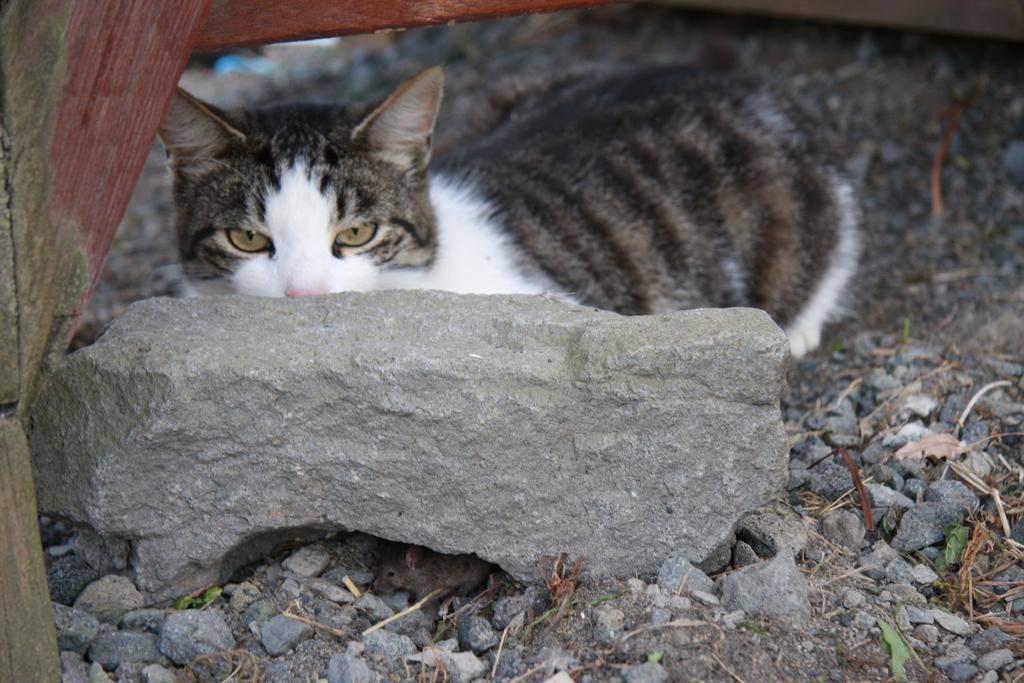Describe this image in one or two sentences. In this picture I can see there is a cat sitting behind a rock and there is a rat here and there are few stones and soil on the floor. 